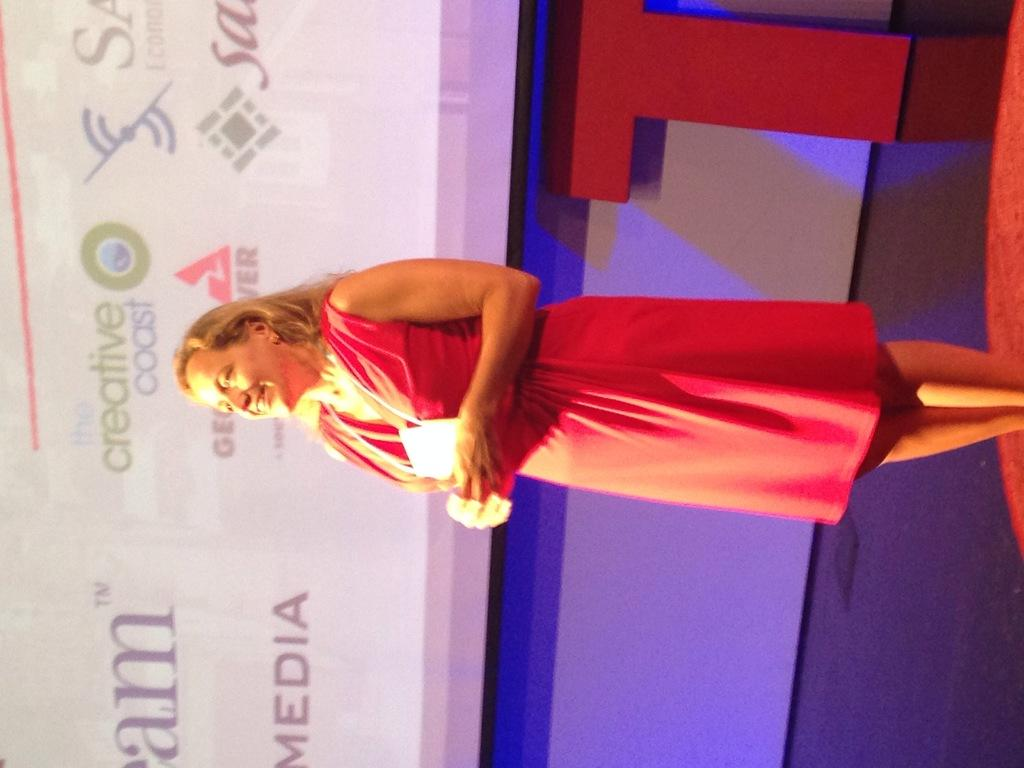Who is the main subject in the image? There is a woman in the image. What is the woman wearing? The woman is wearing a pink dress. What is the woman holding in the image? The woman is holding a document. What is the woman's facial expression? The woman is smiling. Where is the woman standing in the image? The woman is standing on a stage. What can be seen in the background of the image? There is a screen arranged in the background and a wall. What type of vegetable is the woman pulling out of her pocket in the image? There is no vegetable present in the image, and the woman is not pulling anything out of her pocket. Is there a sofa visible in the image? No, there is no sofa present in the image. 